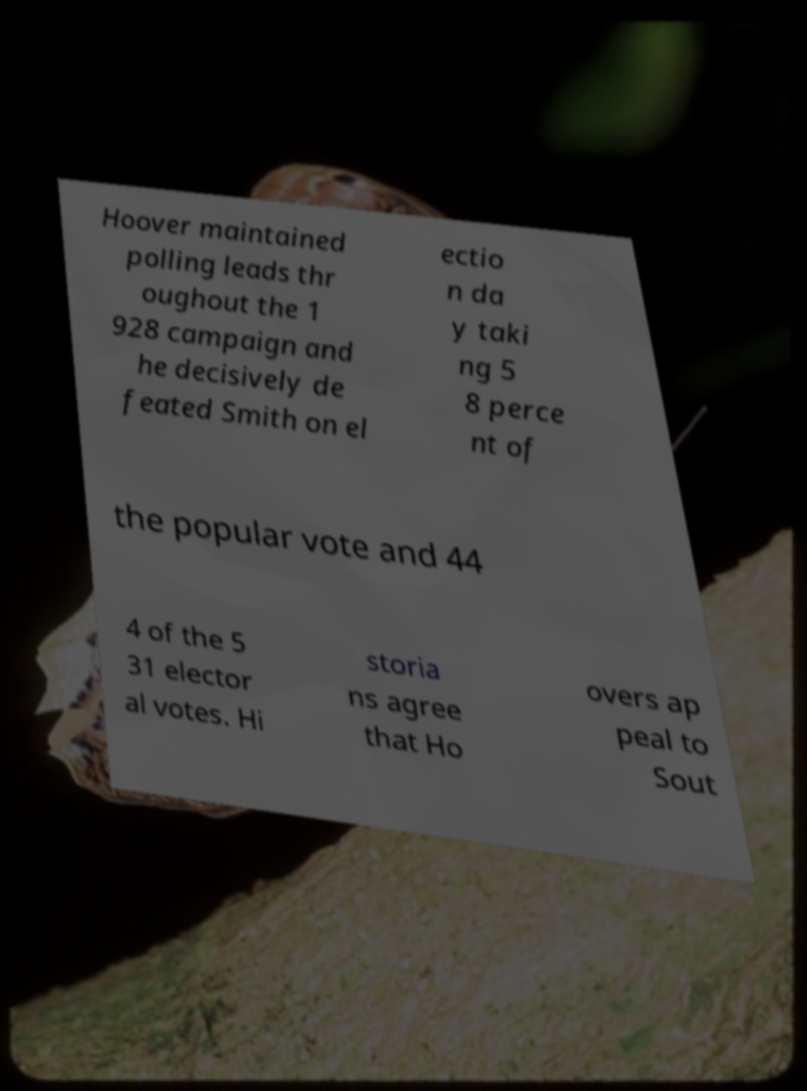Please identify and transcribe the text found in this image. Hoover maintained polling leads thr oughout the 1 928 campaign and he decisively de feated Smith on el ectio n da y taki ng 5 8 perce nt of the popular vote and 44 4 of the 5 31 elector al votes. Hi storia ns agree that Ho overs ap peal to Sout 